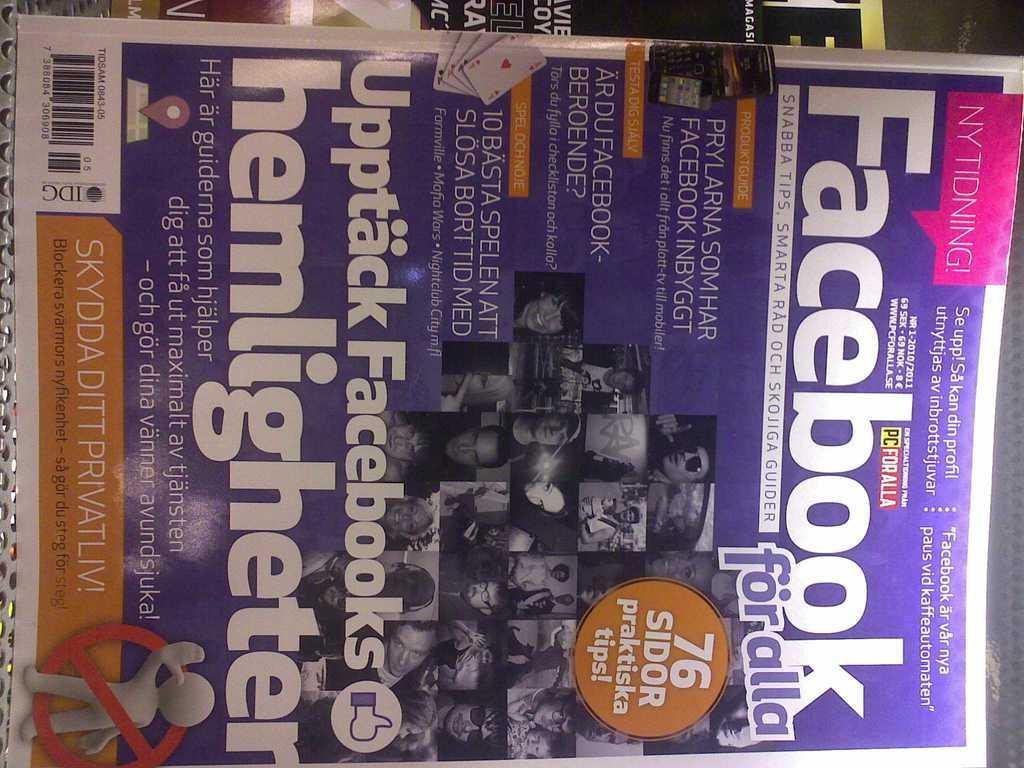<image>
Provide a brief description of the given image. A magazine has seventy six tips in an article in it. 